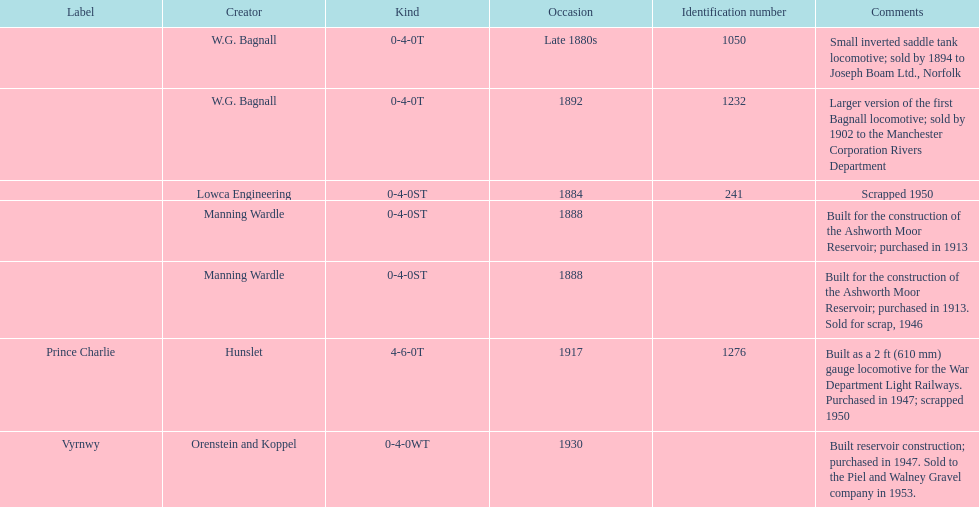Identify all the manufacturers with a locomotive that was scrapped. Lowca Engineering, Manning Wardle, Hunslet. 